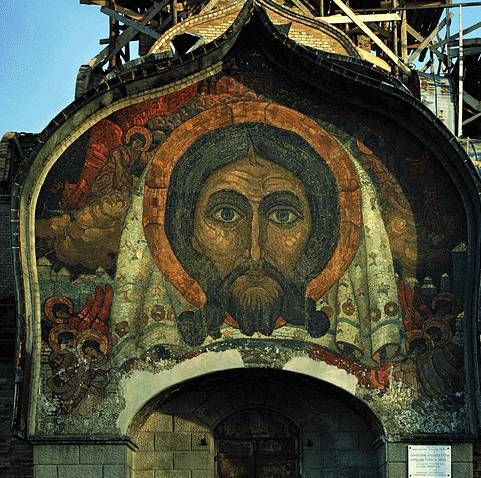What can you tell me about the historical context in which this mosaic was created? This mosaic, showcasing the face of Jesus Christ, is a vibrant example of Byzantine religious art, an art movement that flourished from the 4th to the 15th century. Byzantine mosaics were particularly prominent in the Eastern Roman Empire, known for their deeply spiritual and symbolic nature. The use of gold backgrounds, as seen here, was intended to create a sense of the divine and eternal. These mosaics were often created for churches and were meant to teach and inspire worshippers through their visual splendor. This piece likely served both a decorative and didactic purpose, reinforcing religious teachings and providing a focal point for prayer and contemplation. The ongoing restoration work seen in the image suggests that such historical artifacts are still valued and preserved today. How were these mosaics typically constructed in the Byzantine era? Byzantine mosaics were crafted using small, closely set pieces of colored glass, stone, or ceramic known as tesserae. Artisans would first create a detailed sketch on the wall or ceiling where the mosaic would be placed. This sketch would then serve as a guide for setting the tesserae. Each tessera was meticulously cut and placed into a bed of wet plaster or mortar. Gold leaf was often applied to glass tesserae to achieve the luminous effect seen in many Byzantine mosaics. The construction process required significant skill and precision, as the artisans had to ensure that each piece was correctly positioned to create a cohesive and striking final image. These mosaics were not only works of art but also reflections of the theological and philosophical ideals of the Byzantine period. Imagine if this mosaic could communicate, what stories would it tell us about its creation and the times it has witnessed? If this mosaic could speak, it would likely share a myriad of stories from its creation in a bustling Byzantine workshop, where skilled artisans painstakingly placed each tessera. The mosaic might recount the chattering of the workers, the scent of wet plaster, and the artist's vision guiding its creation. It could tell tales of the grand ceremonies and solemn prayers that it has overseen, standing as a silent witness to centuries of devotion. Through times of peace and upheaval, it might describe how it remained a beacon of faith and hope for countless generations. It could also share stories of the people who have admired its intricate beauty, from the faithful parishioners to the modern restorers, each adding to its rich tapestry of history. 